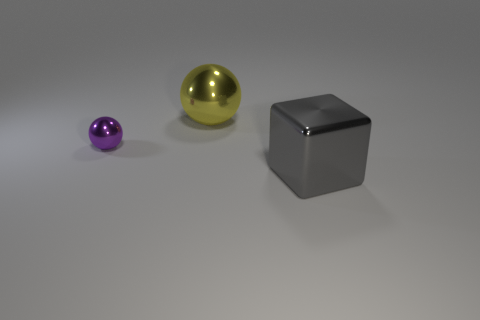Add 3 tiny metal blocks. How many objects exist? 6 Subtract all spheres. How many objects are left? 1 Subtract 0 brown cylinders. How many objects are left? 3 Subtract all big brown cylinders. Subtract all gray blocks. How many objects are left? 2 Add 1 small purple metallic things. How many small purple metallic things are left? 2 Add 2 spheres. How many spheres exist? 4 